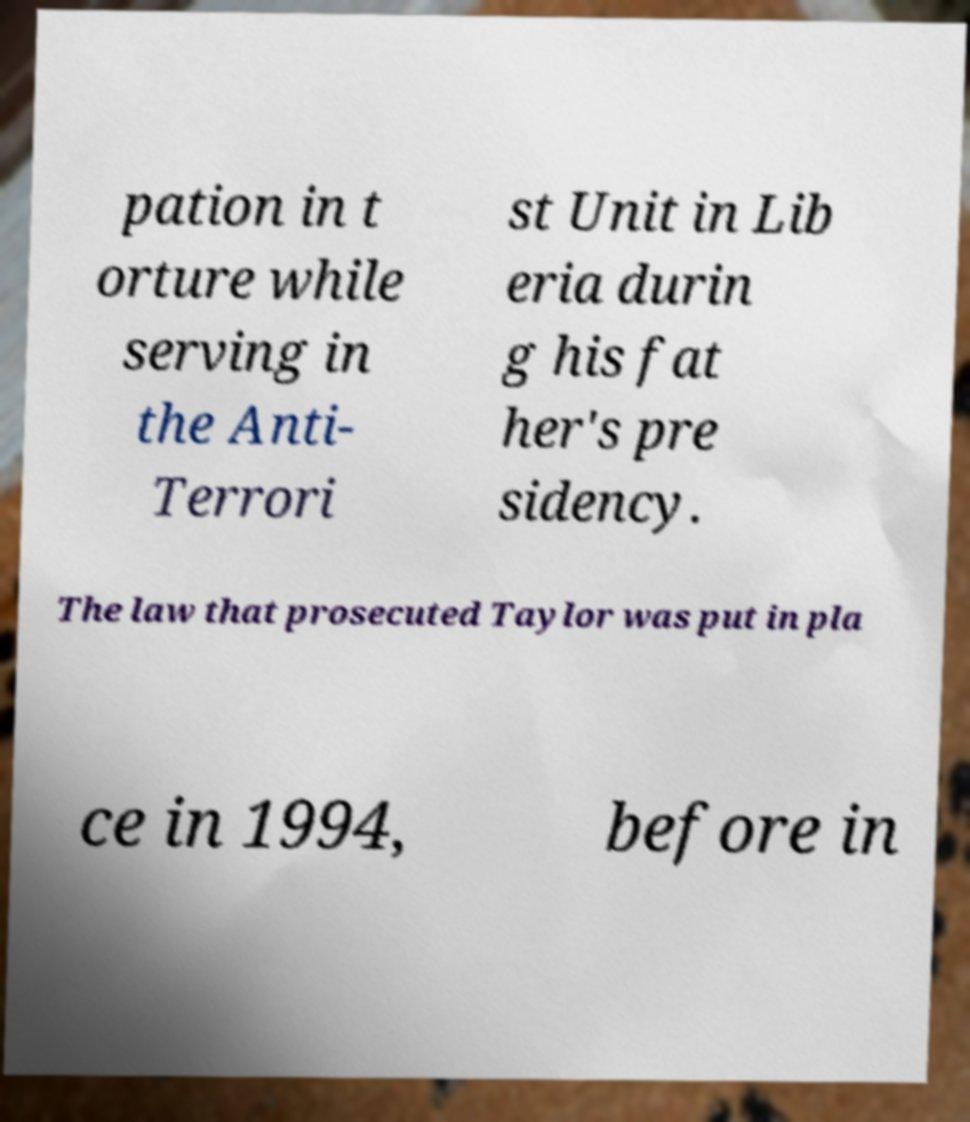Could you extract and type out the text from this image? pation in t orture while serving in the Anti- Terrori st Unit in Lib eria durin g his fat her's pre sidency. The law that prosecuted Taylor was put in pla ce in 1994, before in 